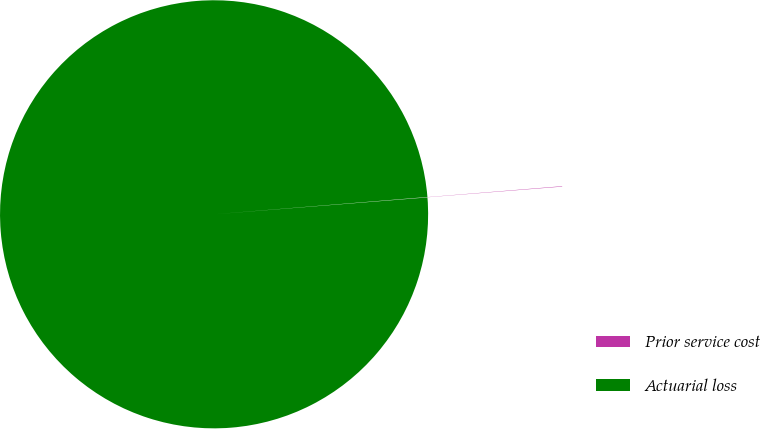<chart> <loc_0><loc_0><loc_500><loc_500><pie_chart><fcel>Prior service cost<fcel>Actuarial loss<nl><fcel>0.03%<fcel>99.97%<nl></chart> 